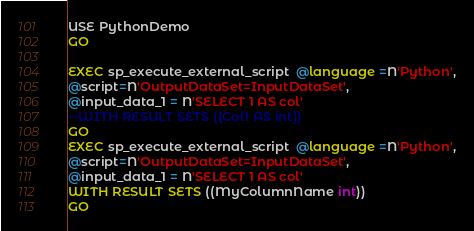Convert code to text. <code><loc_0><loc_0><loc_500><loc_500><_SQL_>USE PythonDemo
GO

EXEC sp_execute_external_script  @language =N'Python',
@script=N'OutputDataSet=InputDataSet',
@input_data_1 = N'SELECT 1 AS col'
--WITH RESULT SETS ((Col1 AS int))
GO
EXEC sp_execute_external_script  @language =N'Python',
@script=N'OutputDataSet=InputDataSet',
@input_data_1 = N'SELECT 1 AS col'
WITH RESULT SETS ((MyColumnName int))
GO</code> 